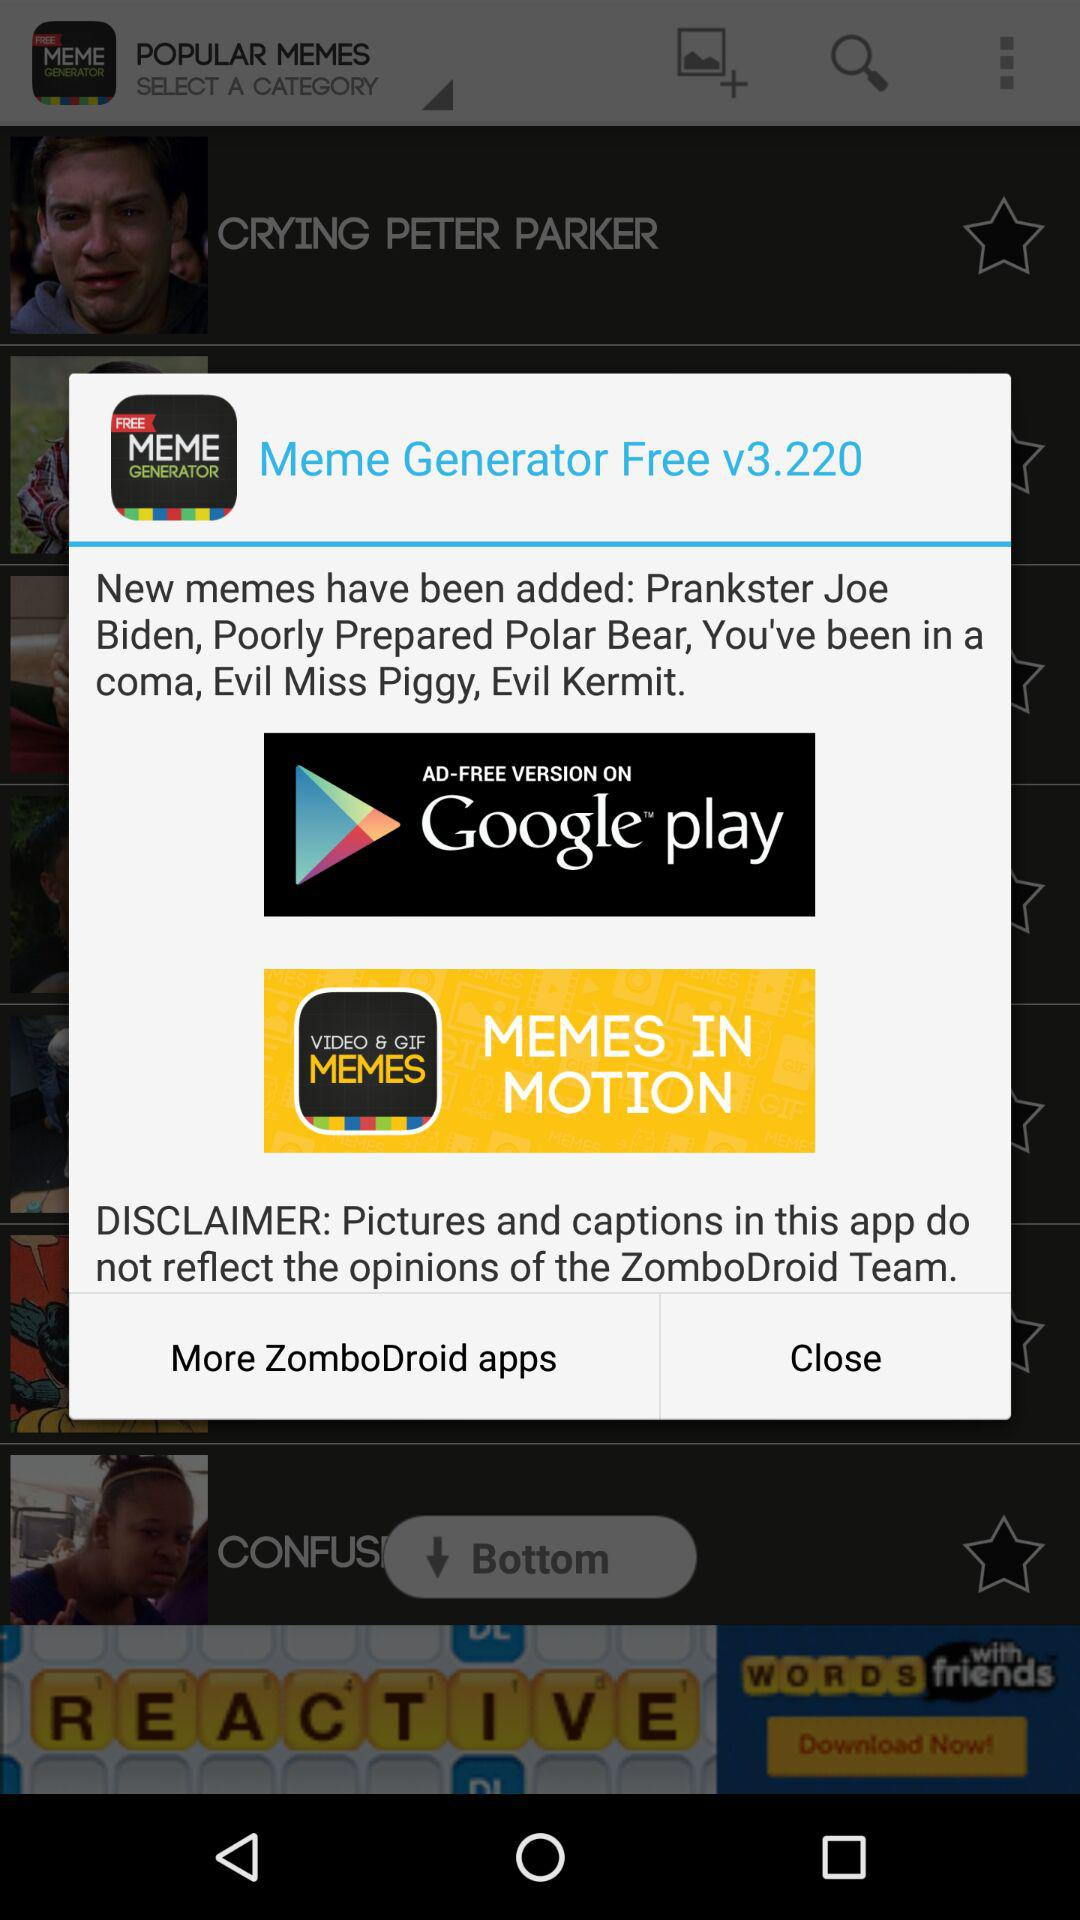What are the names of the new memes that have been added? The names of the new memes that have been added are "Prankster Joe Biden", "Poorly Prepared Polar Bear", "You've been in a coma", "Evil Miss Piggy" and "Evil Kermit". 